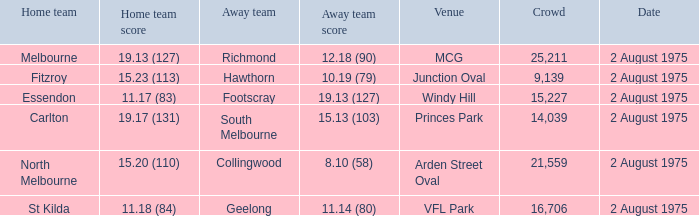When was the event at arden street oval held? 2 August 1975. 